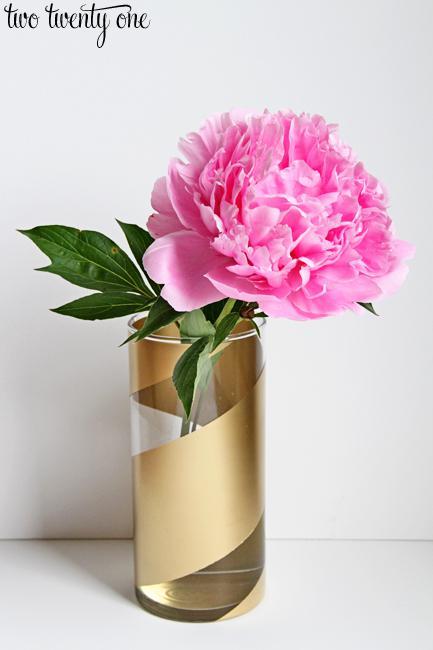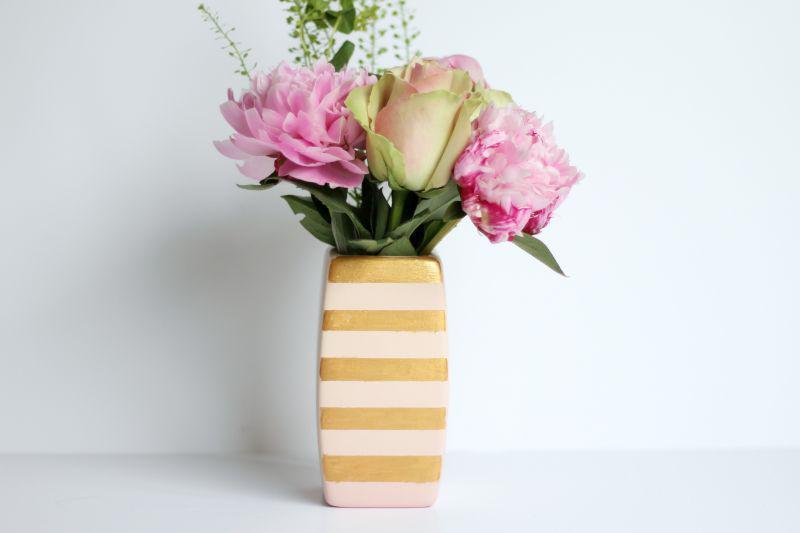The first image is the image on the left, the second image is the image on the right. For the images shown, is this caption "There are more vases in the image on the left." true? Answer yes or no. No. 